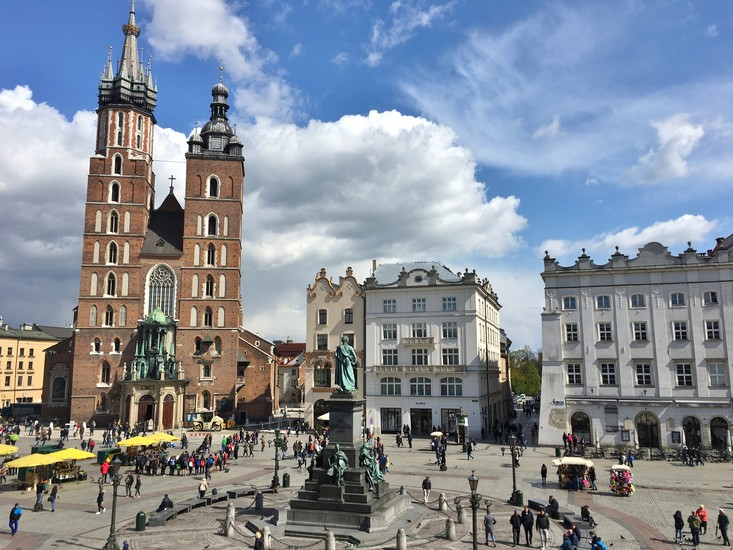If I visit this square, what local delicacies should I try? When visiting Krakow's Main Market Square, you must indulge in some traditional Polish delicacies. Start with pierogi, delicious dumplings filled with various ingredients such as potato and cheese, meat, or even sweet fruits. Another must-try is the famous obwarzanek krakowski, a twisted ring-shaped bread that's chewy, slightly salty, and often sprinkled with poppy seeds or sesharegpt4v/same seeds—a perfect snack for wandering the square.

For something heartier, go for a plate of bigos, a savory stew made from sauerkraut, fresh cabbage, various cuts of meat, and seasoned with spices. And don't miss out on trying the local kielbasa, a flavorful sausage variety that pairs wonderfully with a slice of hearty Polish bread and a dollop of spicy mustard.

Finish your culinary adventure with a taste of paczki, deliciously indulgent Polish doughnuts filled with sweet jams or creams. Pair these treats with a cup of strong Polish coffee or a glass of refreshing local beer, and you'll have experienced the true flavors of Krakow. 